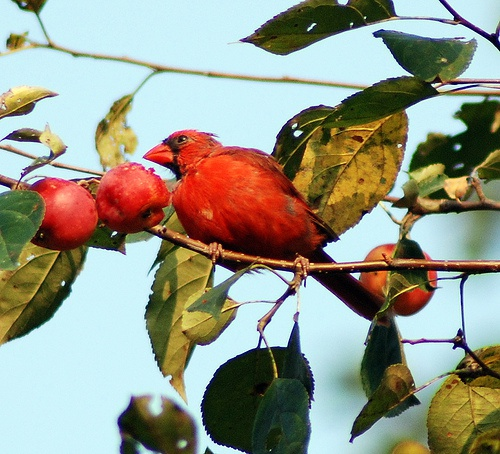Describe the objects in this image and their specific colors. I can see bird in lightblue, red, black, brown, and maroon tones, apple in lightblue, red, salmon, brown, and maroon tones, apple in lightblue, black, maroon, olive, and brown tones, and apple in lightblue, olive, and orange tones in this image. 